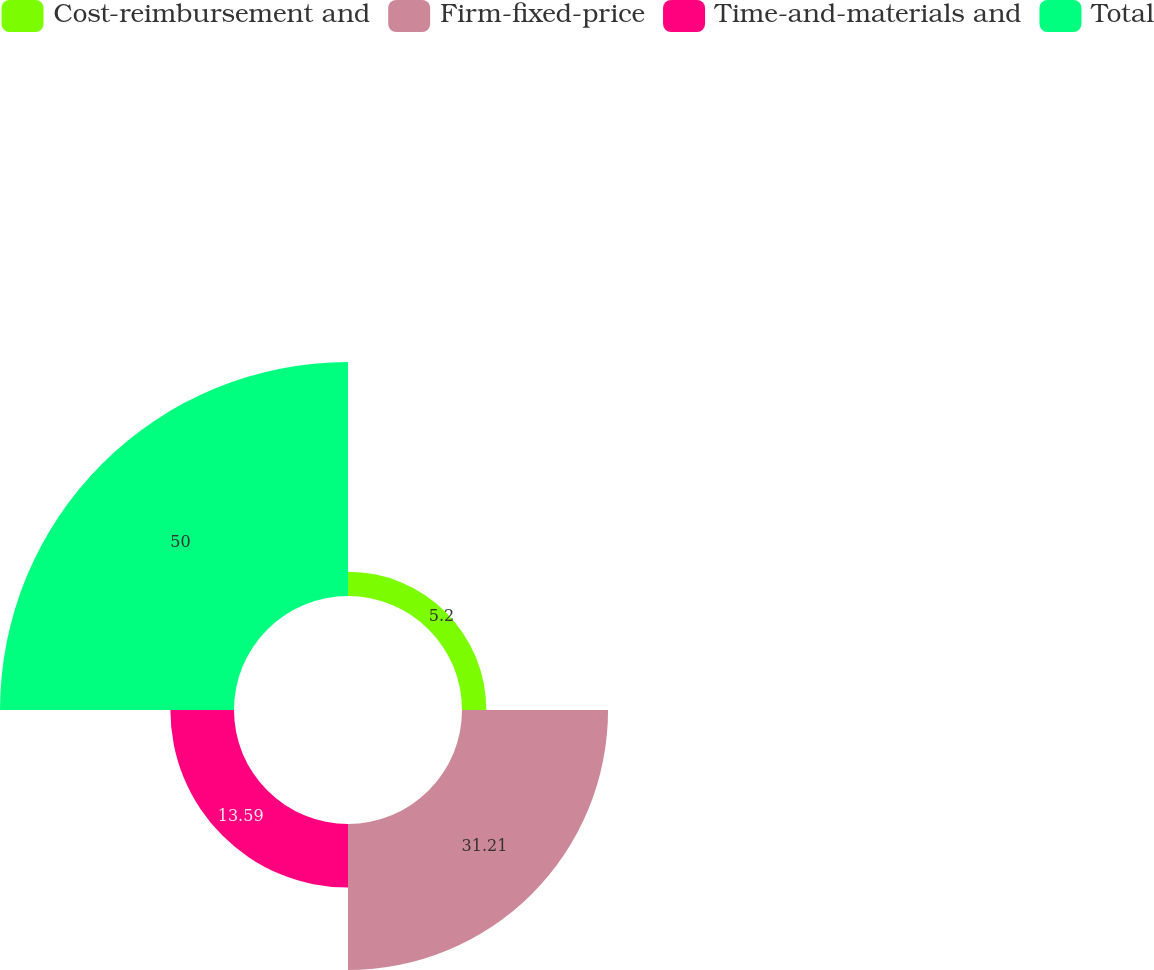Convert chart to OTSL. <chart><loc_0><loc_0><loc_500><loc_500><pie_chart><fcel>Cost-reimbursement and<fcel>Firm-fixed-price<fcel>Time-and-materials and<fcel>Total<nl><fcel>5.2%<fcel>31.21%<fcel>13.59%<fcel>50.0%<nl></chart> 